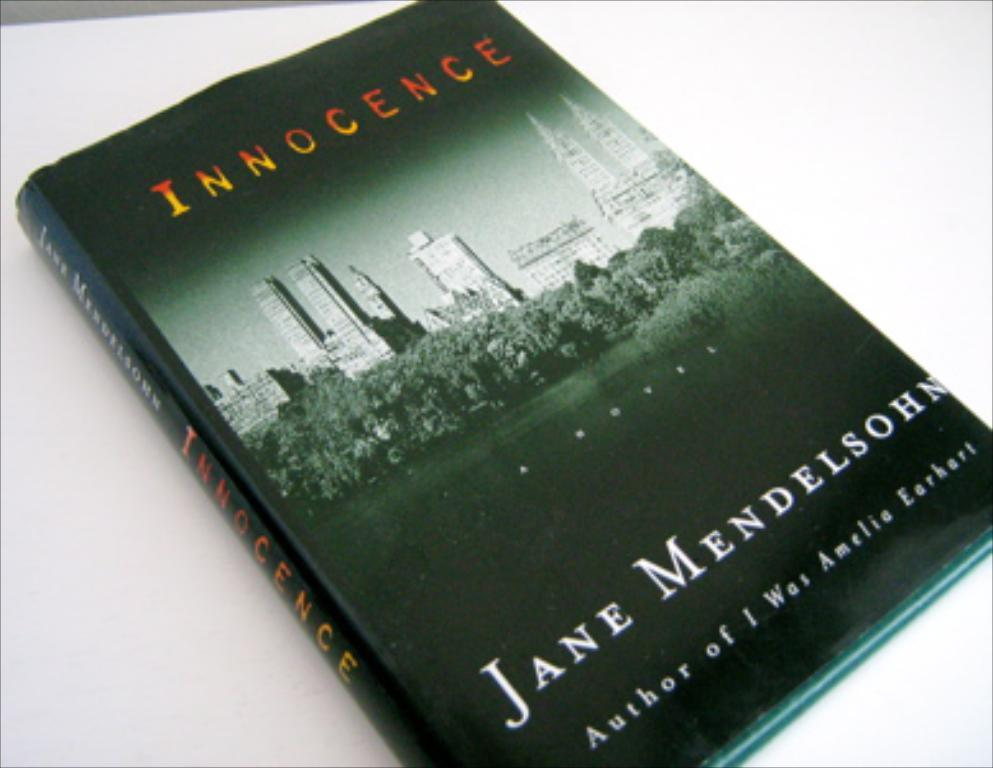<image>
Share a concise interpretation of the image provided. The book called Innocence written by Jane Mendelsohn 